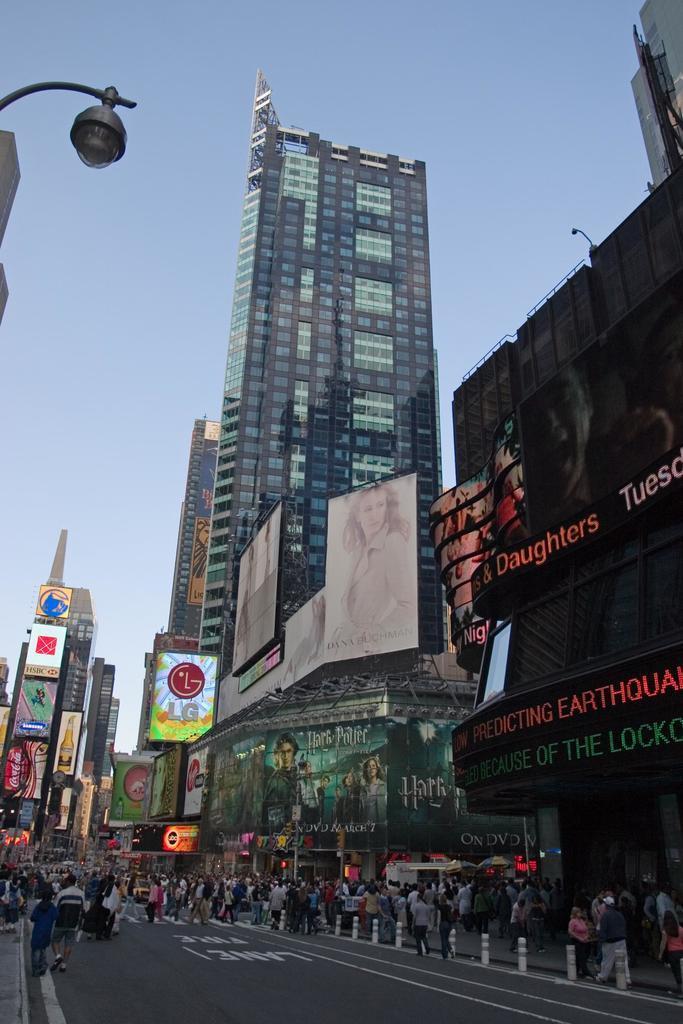How would you summarize this image in a sentence or two? Here we can see people. Background there are buildings with hoardings and glass windows. Sky is in blue color. 